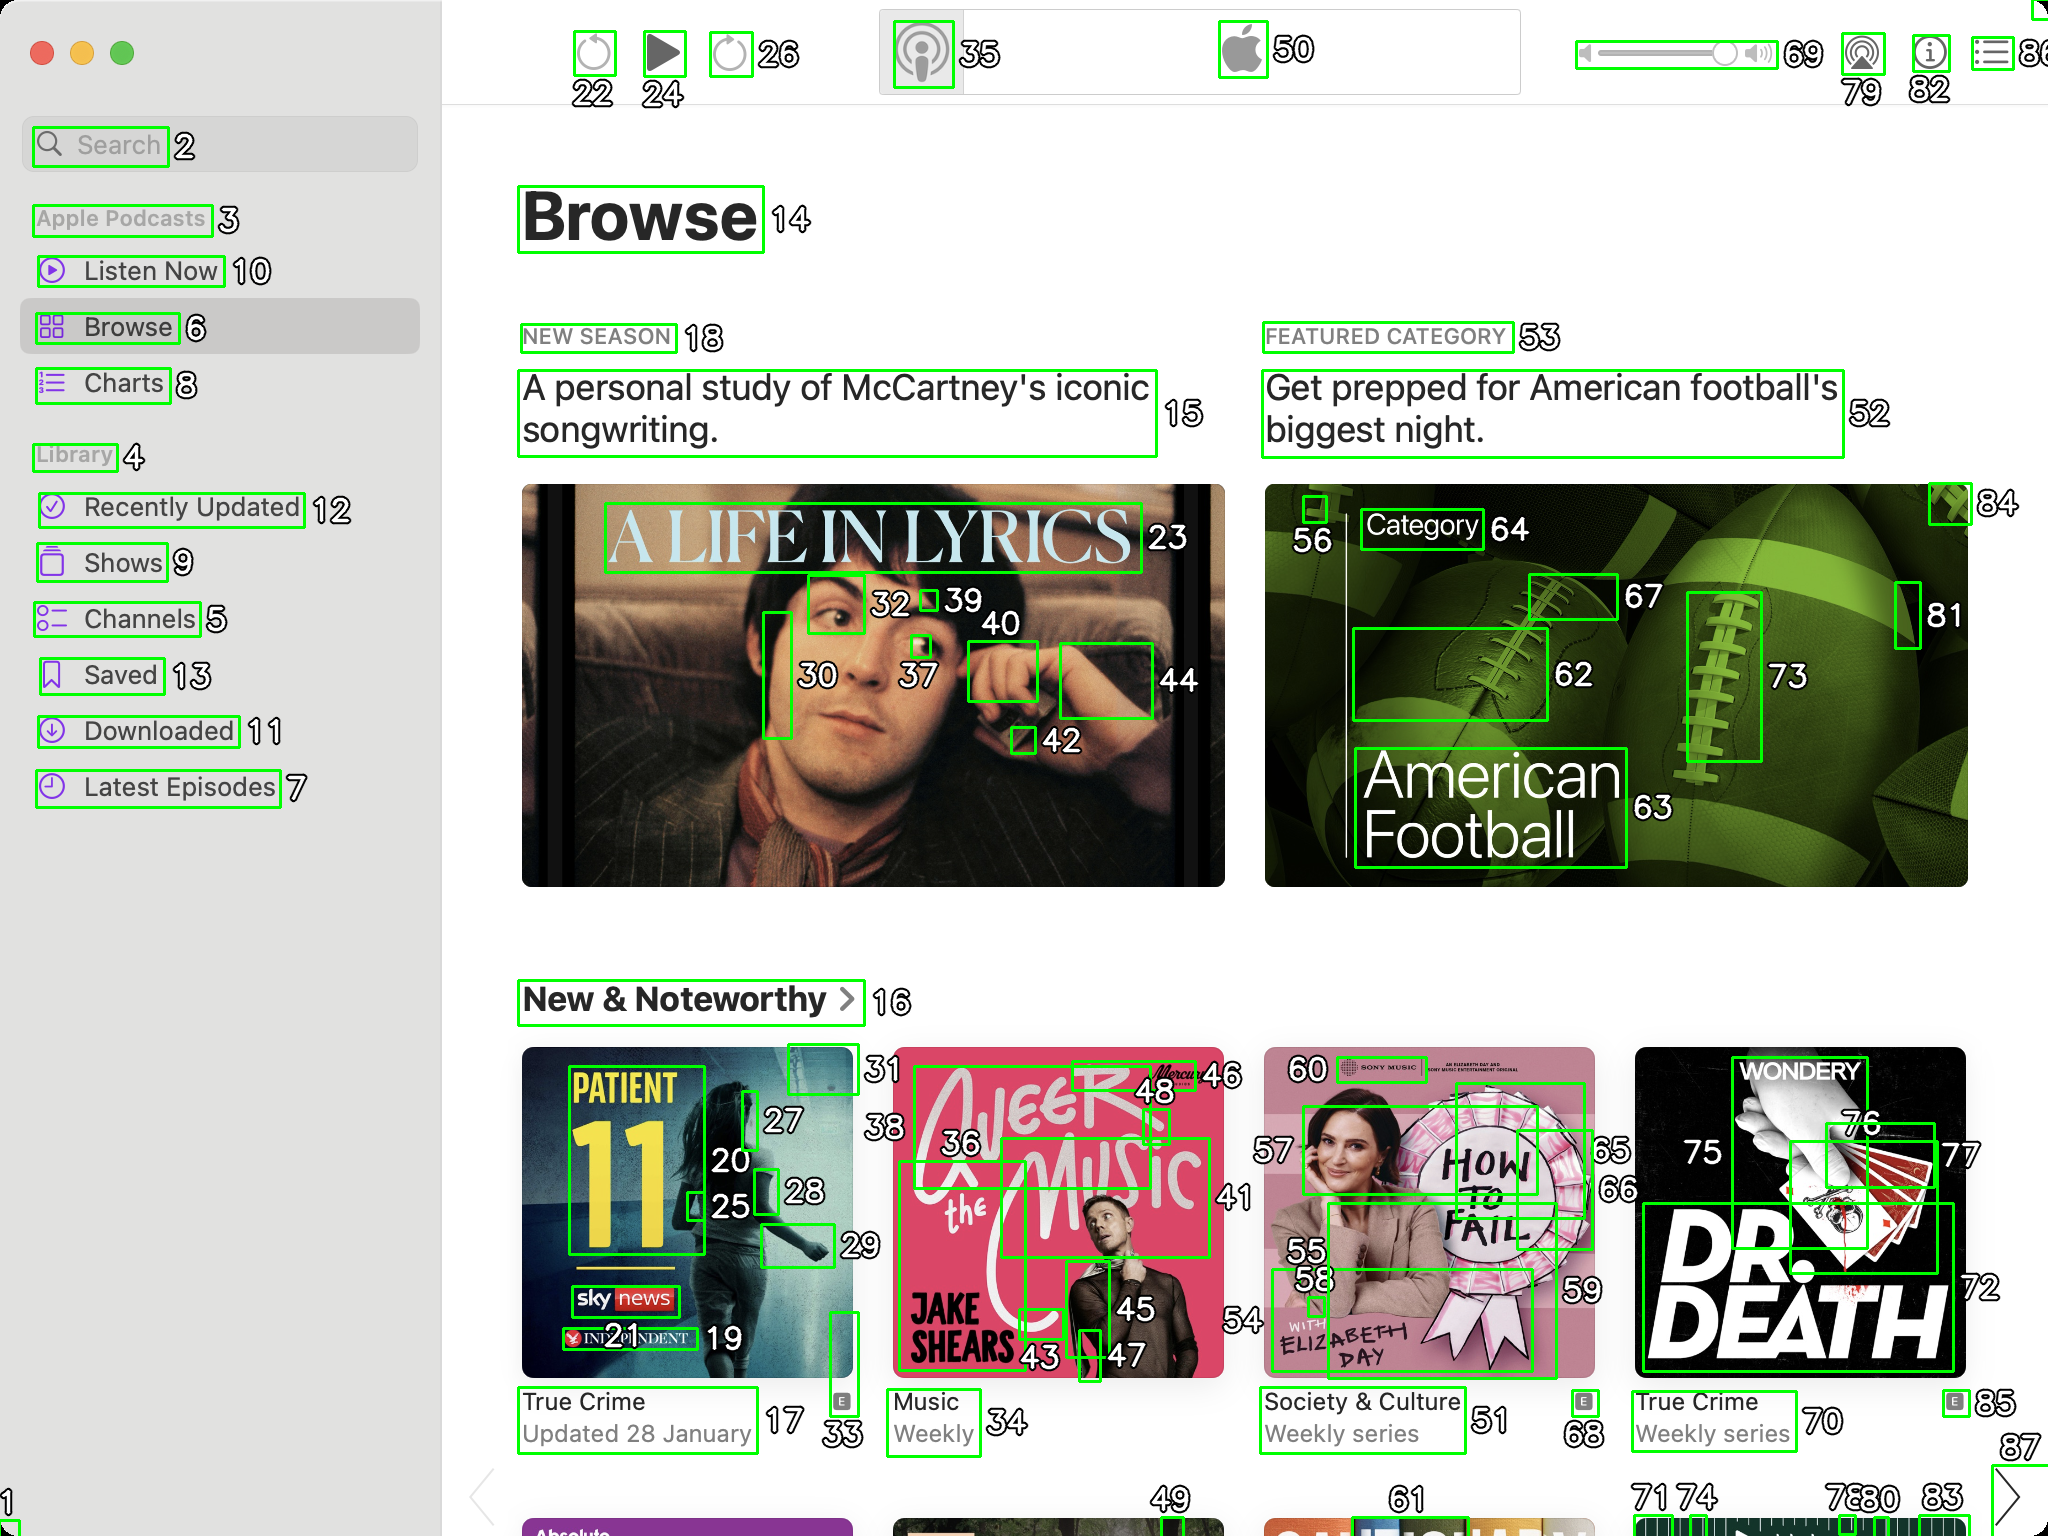You are an AI designed for image processing and segmentation analysis, particularly skilled in merging segmented regions of an image to improve accuracy and readability.

**Task Description:**
Your task is to address a user's concern with a UI screenshot of the Apple Podcasts application on MacOS. The screenshot contains multiple green boxes, each representing a UI element, with a unique white number outlined in black ranging from 1 to 88. Due to segmentation issues, some boxes that belong to the same image are divided unnaturally.

**Objective:**
Merge these segmented areas that correspond to a single UI element to create a coherent representation. The final output should be in JSON format, where each key-value pair represents the merged areas.

**Example JSON Output:**
If boxes with numbers 1, 2, and 3 should belong to the same UI element, the JSON output should be:

```json
{
    "Image A Life In Lyrics": [1, 2, 3]
}
```

**Instructions:**

- **Identify Segmented Regions:** Analyze the screenshot to identify which green boxes belong to the same UI element.
- **Merge Regions:** Group the numbers of these boxes together to represent a single UI element.
- **Output Format:** Produce the output in JSON format, with each key representing a UI element and each value being a list of the numbers of the merged boxes. Don't include in the result UI elements that consist of one box.

**Primary Objective:**
Ensure the accuracy of the merged regions based on the user's supplied image information, maintaining the integrity and structure of the UI elements in the Apple Podcasts application on MacOS. Based on the provided screenshot and the task description, here is the JSON output representing the merged segmented areas that correspond to single UI elements:

```json
{
    "Search": [2],
    "Apple Podcasts": [3],
    "Listen Now": [10],
    "Browse": [6, 14],
    "Charts": [8],
    "Library": [4],
    "Recently Updated": [12],
    "Shows": [9],
    "Channels": [5],
    "Saved": [13],
    "Downloaded": [11],
    "Latest Episodes": [7],
    "A Life In Lyrics": [23, 30, 32, 37, 39, 40, 42, 44],
    "New Season": [18],
    "A personal study of McCartney's iconic songwriting.": [15],
    "Featured Category": [53],
    "Get prepped for American football's biggest night.": [52],
    "Category": [64],
    "American Football": [62, 63, 73, 81, 84],
    "New & Noteworthy": [16],
    "Patient 11": [17, 20, 25, 27, 28, 33],
    "True Crime Updated 28 January": [17],
    "Jake Shears": [36, 43, 45, 46, 48],
    "Music Weekly": [36],
    "How To Fail": [55, 56, 59, 60],
    "Society & Culture Weekly series": [51],
    "Dr. Death": [70, 72, 75, 76, 77],
    "True Crime Weekly series": [70],
    "Wondery": [85],
    "Play": [24],
    "Pause": [26],
    "Volume": [69, 79, 82],
    "Apple Logo": [50],
    "Settings": [22, 35]
}
```

This JSON output groups the segmented areas into coherent UI elements based on the provided screenshot. Each key represents a UI element, and the values are lists of the numbers of the merged boxes. 